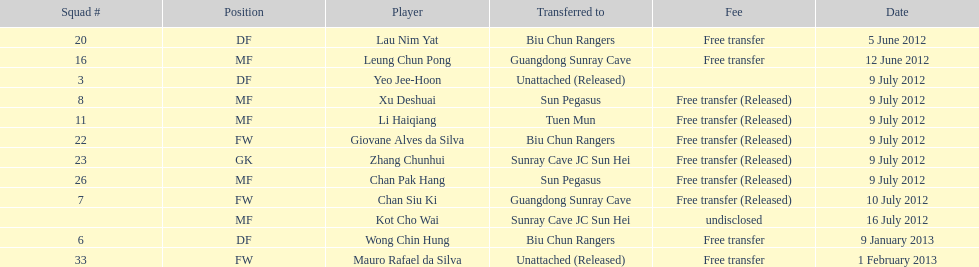Lau nim yat and giovane alves de silva where both transferred to which team? Biu Chun Rangers. 